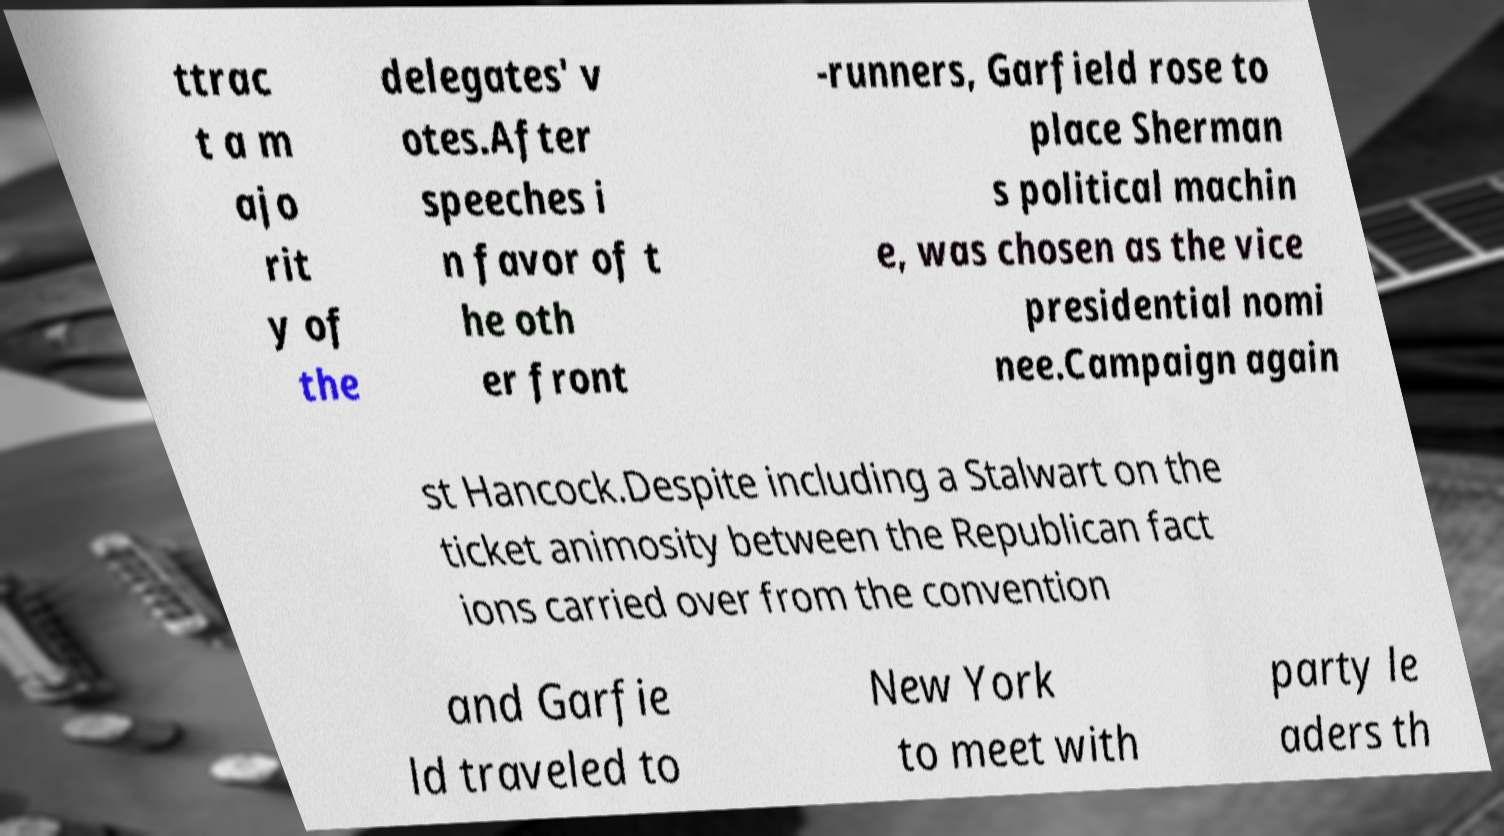Please identify and transcribe the text found in this image. ttrac t a m ajo rit y of the delegates' v otes.After speeches i n favor of t he oth er front -runners, Garfield rose to place Sherman s political machin e, was chosen as the vice presidential nomi nee.Campaign again st Hancock.Despite including a Stalwart on the ticket animosity between the Republican fact ions carried over from the convention and Garfie ld traveled to New York to meet with party le aders th 